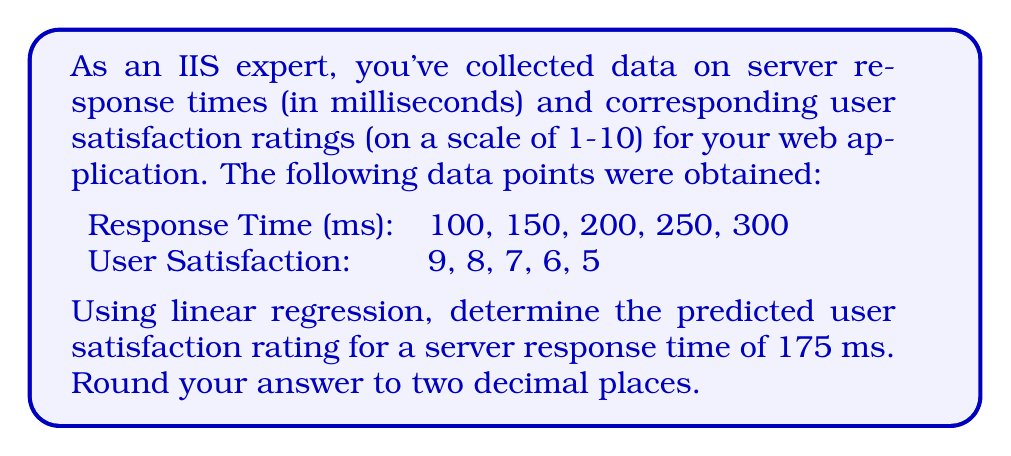What is the answer to this math problem? To solve this problem using linear regression, we'll follow these steps:

1) First, let's calculate the means of x (response time) and y (user satisfaction):
   $\bar{x} = \frac{100 + 150 + 200 + 250 + 300}{5} = 200$
   $\bar{y} = \frac{9 + 8 + 7 + 6 + 5}{5} = 7$

2) Now, we need to calculate the slope (m) of the regression line:
   $m = \frac{\sum (x_i - \bar{x})(y_i - \bar{y})}{\sum (x_i - \bar{x})^2}$

3) Let's calculate the numerator and denominator separately:
   Numerator: $(-100)(2) + (-50)(1) + (0)(0) + (50)(-1) + (100)(-2) = -400$
   Denominator: $(-100)^2 + (-50)^2 + (0)^2 + (50)^2 + (100)^2 = 30000$

4) Now we can calculate the slope:
   $m = \frac{-400}{30000} = -\frac{1}{75} \approx -0.0133$

5) Next, we'll find the y-intercept (b) using the point-slope form:
   $y - \bar{y} = m(x - \bar{x})$
   $b = \bar{y} - m\bar{x} = 7 - (-\frac{1}{75})(200) = 7 + \frac{8}{3} = \frac{29}{3} \approx 9.67$

6) Our regression line equation is:
   $y = mx + b = -\frac{1}{75}x + \frac{29}{3}$

7) To predict the user satisfaction for a response time of 175 ms, we substitute x = 175:
   $y = -\frac{1}{75}(175) + \frac{29}{3} = -\frac{7}{3} + \frac{29}{3} = \frac{22}{3} \approx 7.33$

Therefore, the predicted user satisfaction rating for a server response time of 175 ms is approximately 7.33.
Answer: 7.33 